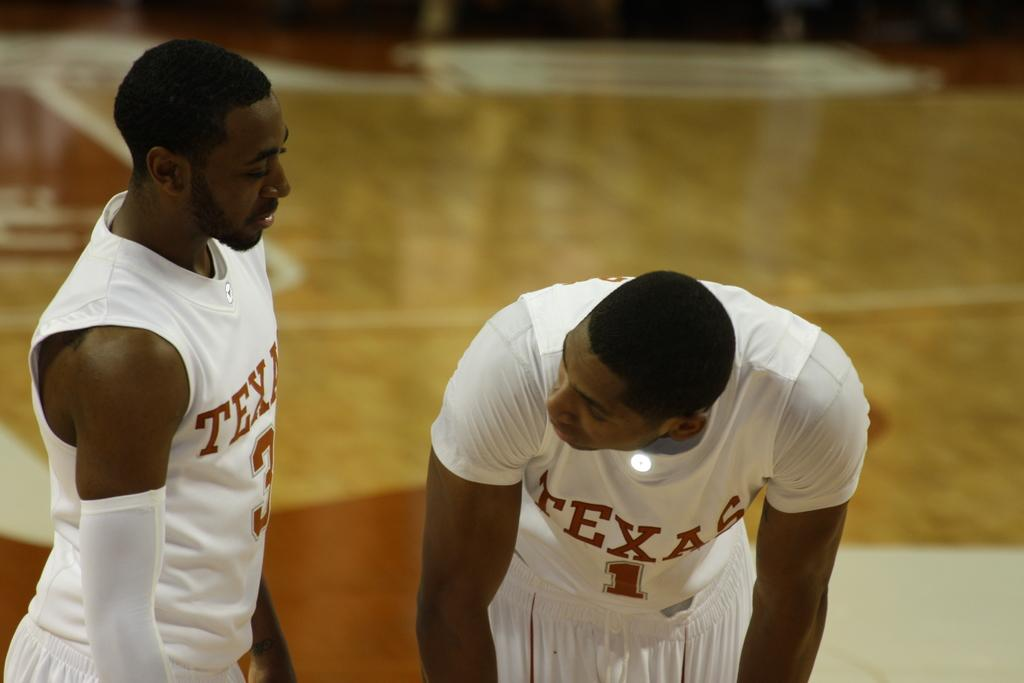<image>
Present a compact description of the photo's key features. a couple of guys with one wearing a Texas jersey 